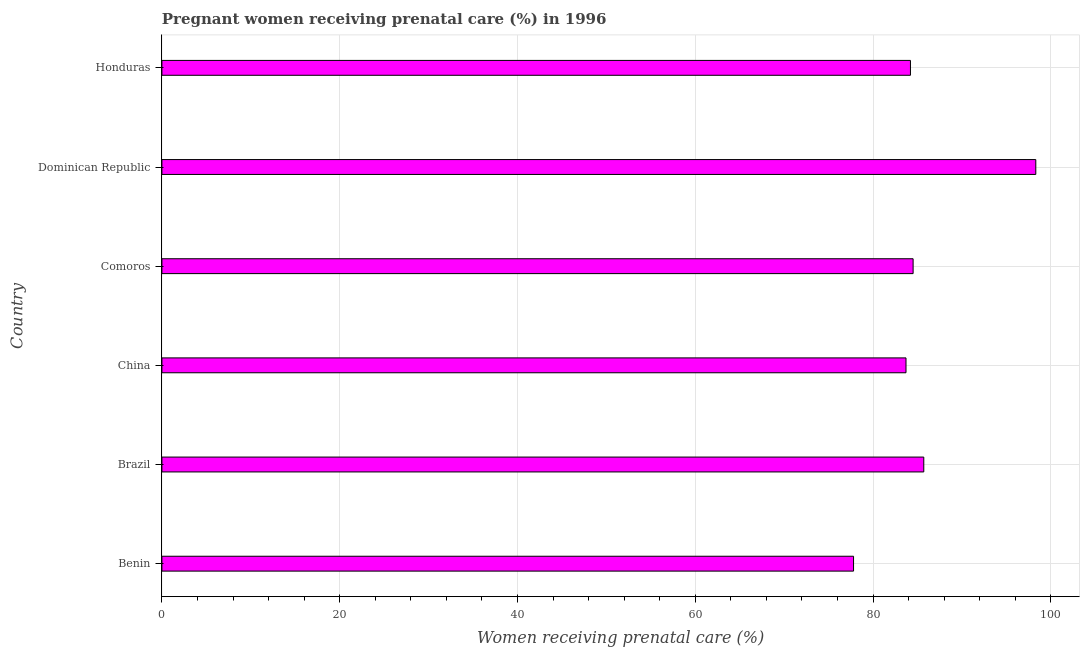Does the graph contain grids?
Your answer should be compact. Yes. What is the title of the graph?
Offer a very short reply. Pregnant women receiving prenatal care (%) in 1996. What is the label or title of the X-axis?
Provide a succinct answer. Women receiving prenatal care (%). What is the label or title of the Y-axis?
Ensure brevity in your answer.  Country. What is the percentage of pregnant women receiving prenatal care in Brazil?
Offer a terse response. 85.7. Across all countries, what is the maximum percentage of pregnant women receiving prenatal care?
Your answer should be compact. 98.3. Across all countries, what is the minimum percentage of pregnant women receiving prenatal care?
Give a very brief answer. 77.8. In which country was the percentage of pregnant women receiving prenatal care maximum?
Keep it short and to the point. Dominican Republic. In which country was the percentage of pregnant women receiving prenatal care minimum?
Give a very brief answer. Benin. What is the sum of the percentage of pregnant women receiving prenatal care?
Your answer should be compact. 514.2. What is the average percentage of pregnant women receiving prenatal care per country?
Provide a short and direct response. 85.7. What is the median percentage of pregnant women receiving prenatal care?
Offer a very short reply. 84.35. What is the ratio of the percentage of pregnant women receiving prenatal care in Benin to that in Comoros?
Provide a short and direct response. 0.92. Is the sum of the percentage of pregnant women receiving prenatal care in Benin and Dominican Republic greater than the maximum percentage of pregnant women receiving prenatal care across all countries?
Offer a very short reply. Yes. How many bars are there?
Provide a succinct answer. 6. How many countries are there in the graph?
Offer a very short reply. 6. What is the difference between two consecutive major ticks on the X-axis?
Make the answer very short. 20. Are the values on the major ticks of X-axis written in scientific E-notation?
Provide a short and direct response. No. What is the Women receiving prenatal care (%) in Benin?
Your response must be concise. 77.8. What is the Women receiving prenatal care (%) in Brazil?
Offer a terse response. 85.7. What is the Women receiving prenatal care (%) of China?
Your answer should be very brief. 83.7. What is the Women receiving prenatal care (%) in Comoros?
Your response must be concise. 84.5. What is the Women receiving prenatal care (%) in Dominican Republic?
Your answer should be compact. 98.3. What is the Women receiving prenatal care (%) of Honduras?
Make the answer very short. 84.2. What is the difference between the Women receiving prenatal care (%) in Benin and Dominican Republic?
Keep it short and to the point. -20.5. What is the difference between the Women receiving prenatal care (%) in Benin and Honduras?
Ensure brevity in your answer.  -6.4. What is the difference between the Women receiving prenatal care (%) in Brazil and Dominican Republic?
Provide a succinct answer. -12.6. What is the difference between the Women receiving prenatal care (%) in China and Dominican Republic?
Your answer should be compact. -14.6. What is the difference between the Women receiving prenatal care (%) in Comoros and Honduras?
Ensure brevity in your answer.  0.3. What is the difference between the Women receiving prenatal care (%) in Dominican Republic and Honduras?
Your response must be concise. 14.1. What is the ratio of the Women receiving prenatal care (%) in Benin to that in Brazil?
Your answer should be very brief. 0.91. What is the ratio of the Women receiving prenatal care (%) in Benin to that in Comoros?
Offer a very short reply. 0.92. What is the ratio of the Women receiving prenatal care (%) in Benin to that in Dominican Republic?
Offer a terse response. 0.79. What is the ratio of the Women receiving prenatal care (%) in Benin to that in Honduras?
Keep it short and to the point. 0.92. What is the ratio of the Women receiving prenatal care (%) in Brazil to that in China?
Your answer should be compact. 1.02. What is the ratio of the Women receiving prenatal care (%) in Brazil to that in Comoros?
Offer a very short reply. 1.01. What is the ratio of the Women receiving prenatal care (%) in Brazil to that in Dominican Republic?
Offer a very short reply. 0.87. What is the ratio of the Women receiving prenatal care (%) in China to that in Dominican Republic?
Your answer should be compact. 0.85. What is the ratio of the Women receiving prenatal care (%) in China to that in Honduras?
Your answer should be very brief. 0.99. What is the ratio of the Women receiving prenatal care (%) in Comoros to that in Dominican Republic?
Offer a terse response. 0.86. What is the ratio of the Women receiving prenatal care (%) in Comoros to that in Honduras?
Keep it short and to the point. 1. What is the ratio of the Women receiving prenatal care (%) in Dominican Republic to that in Honduras?
Offer a terse response. 1.17. 